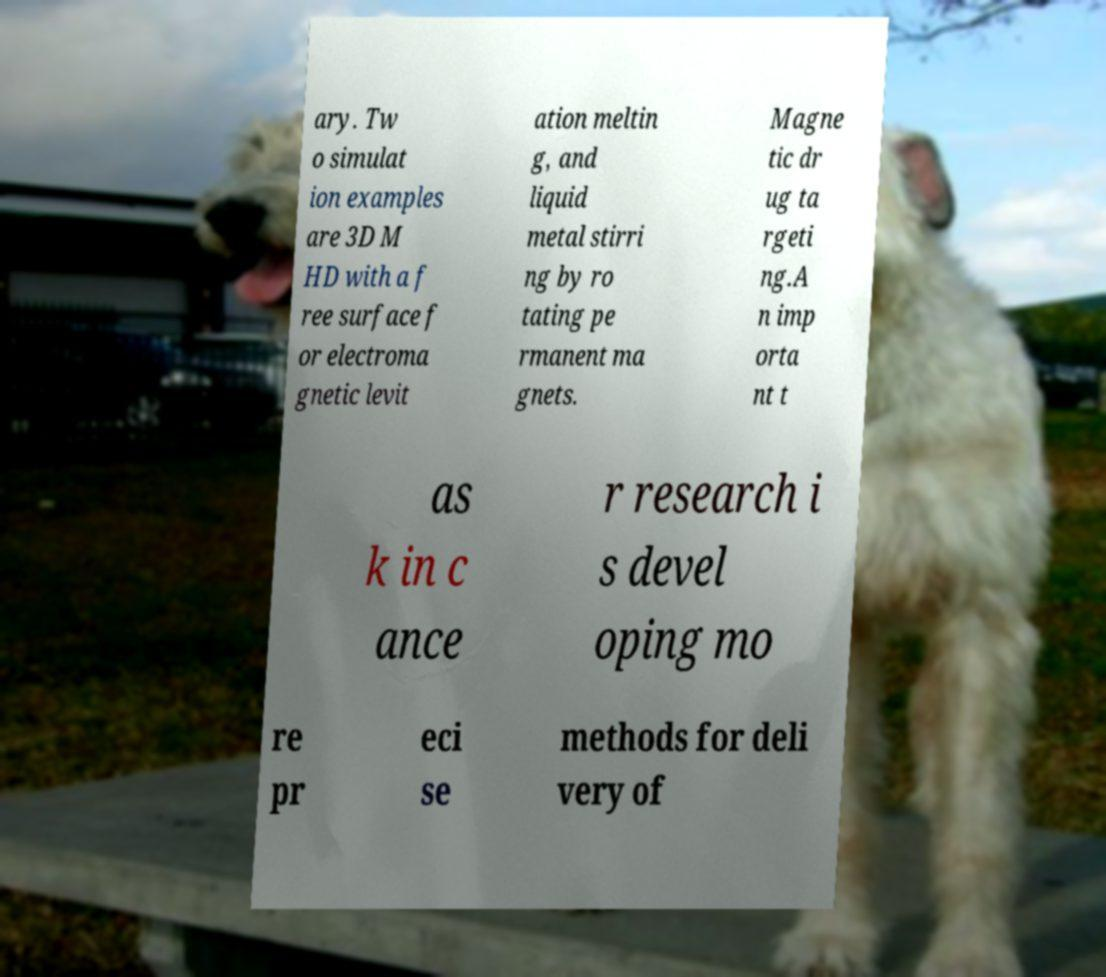Please read and relay the text visible in this image. What does it say? ary. Tw o simulat ion examples are 3D M HD with a f ree surface f or electroma gnetic levit ation meltin g, and liquid metal stirri ng by ro tating pe rmanent ma gnets. Magne tic dr ug ta rgeti ng.A n imp orta nt t as k in c ance r research i s devel oping mo re pr eci se methods for deli very of 